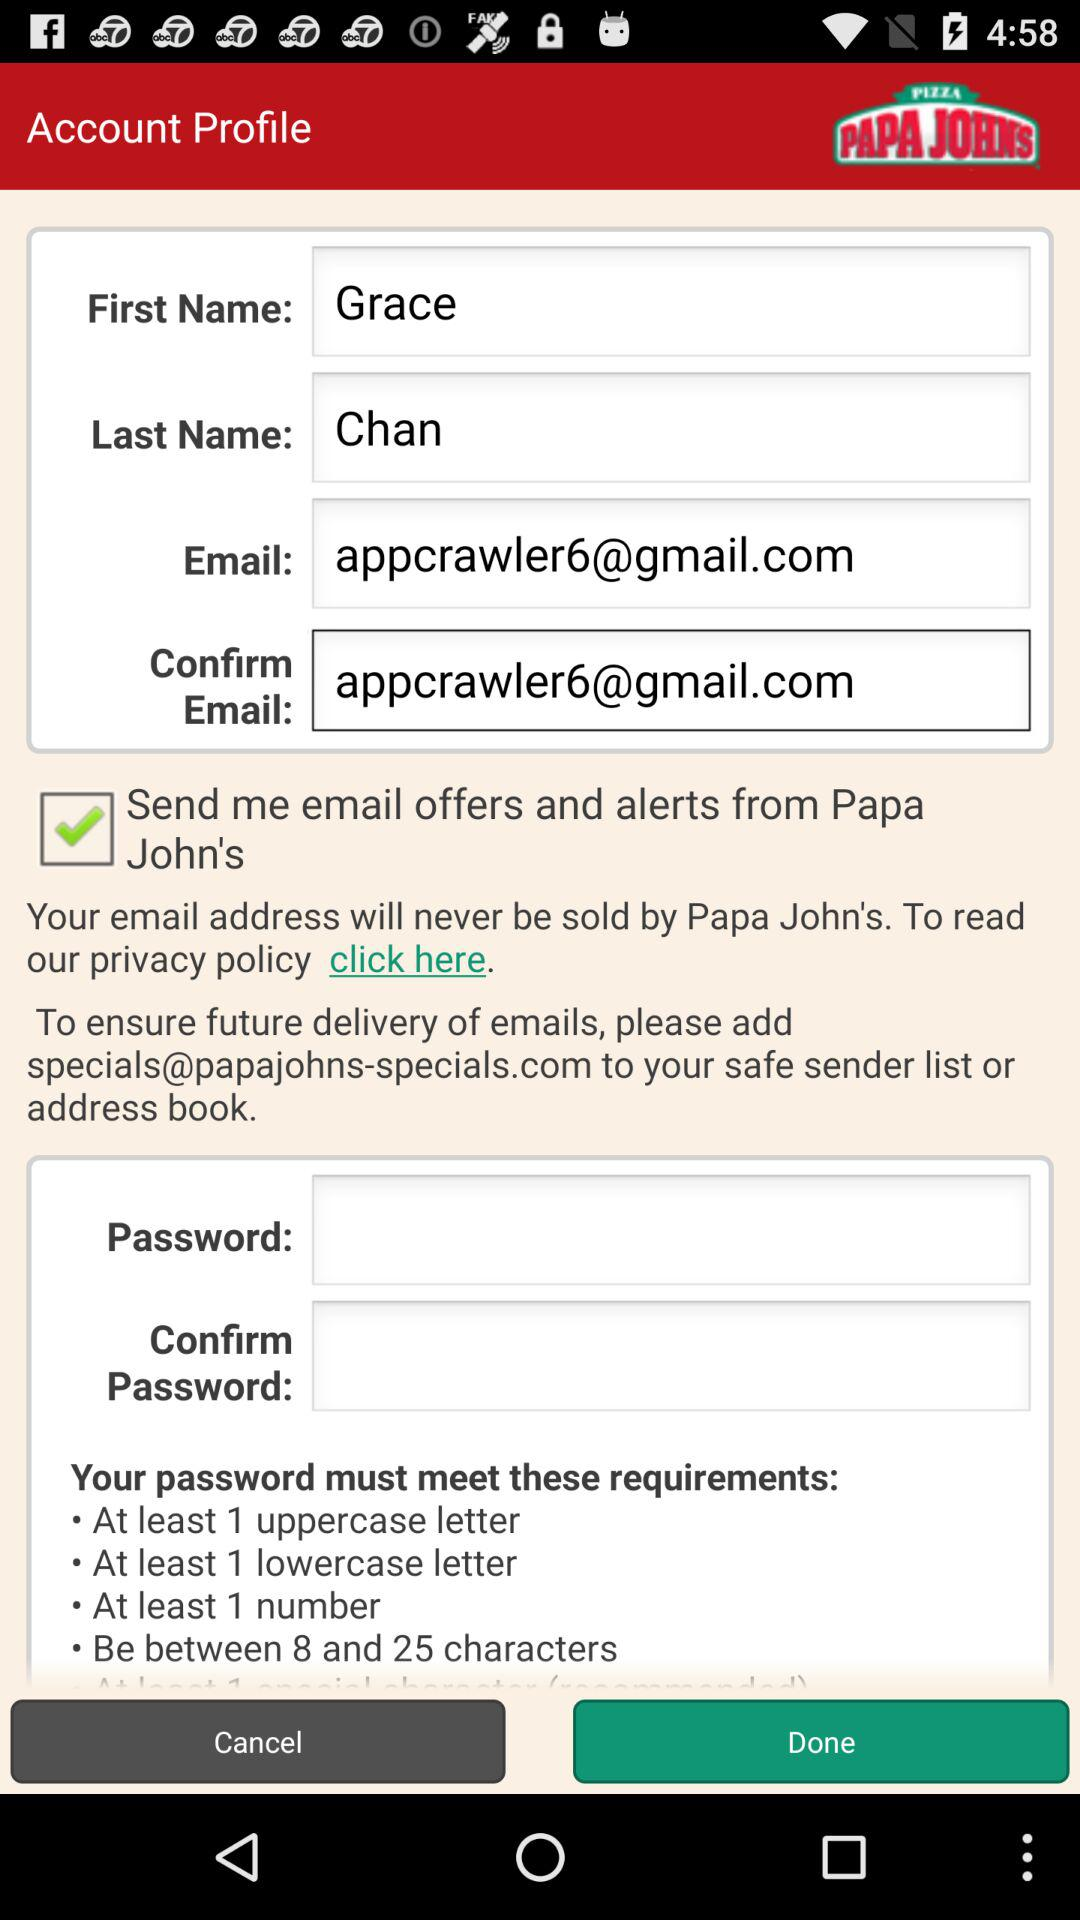What is the first name? The first name is Grace. 